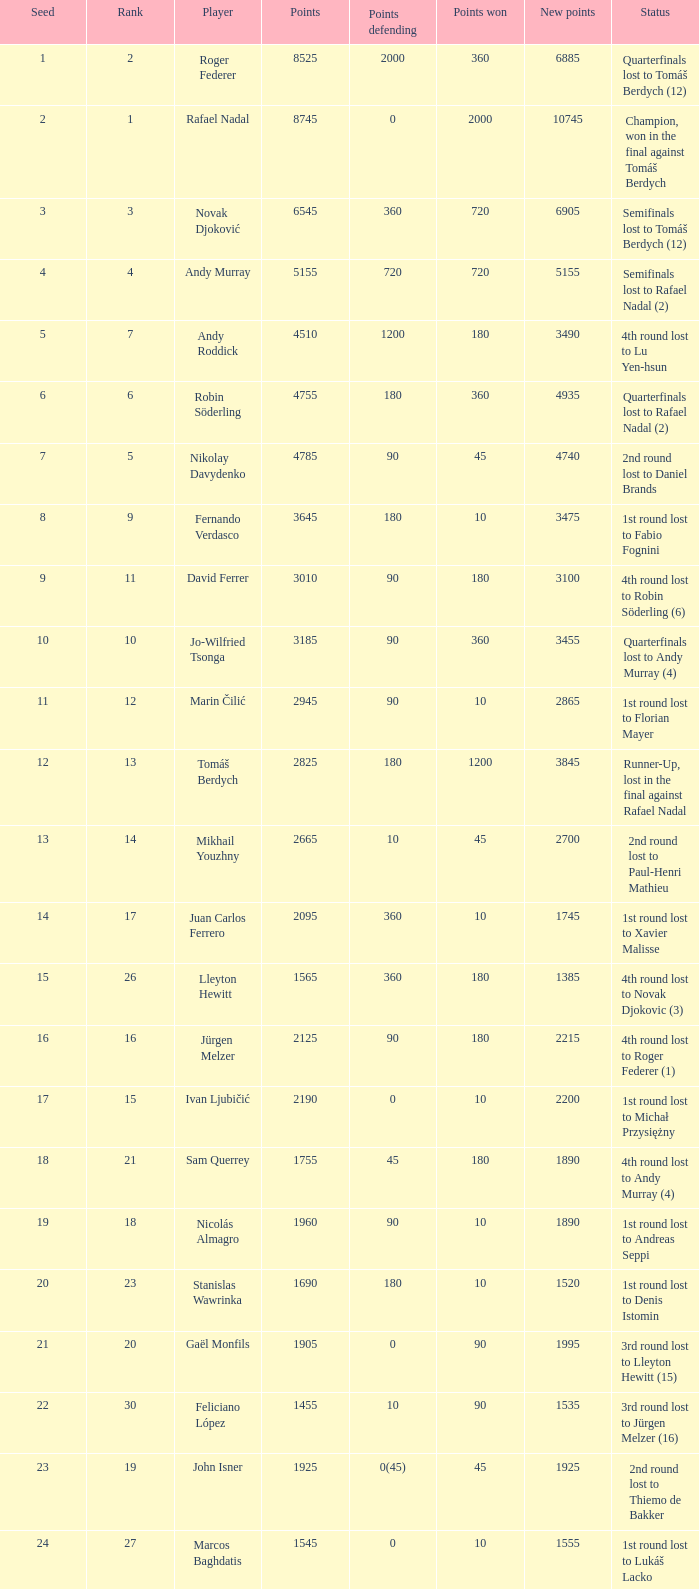Identify the points earned for a score of 1230. 90.0. 